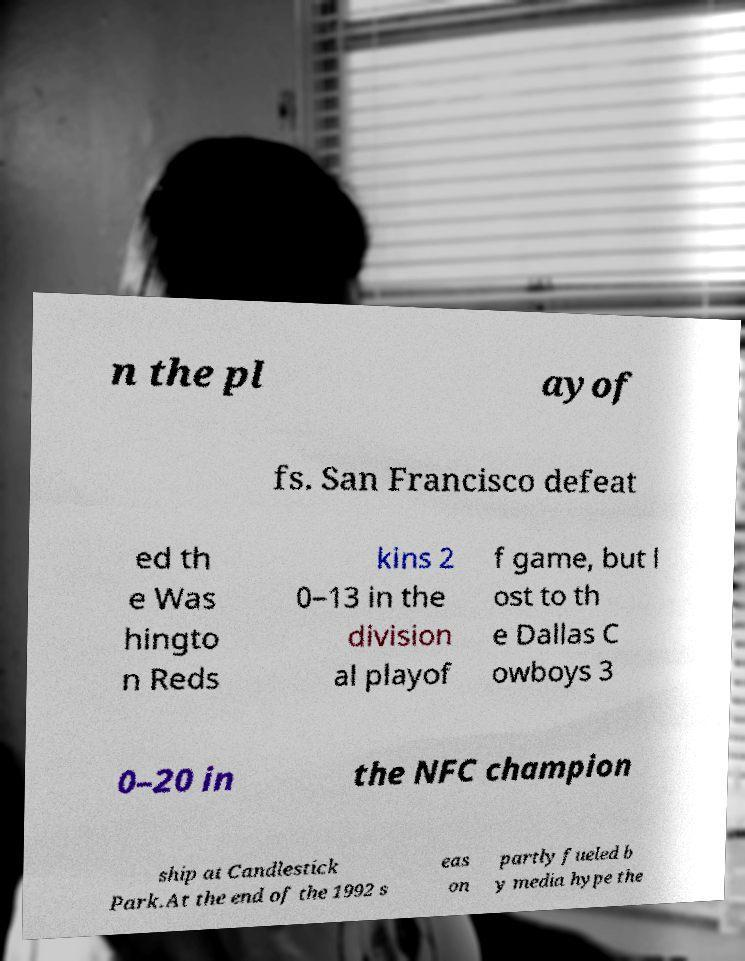I need the written content from this picture converted into text. Can you do that? n the pl ayof fs. San Francisco defeat ed th e Was hingto n Reds kins 2 0–13 in the division al playof f game, but l ost to th e Dallas C owboys 3 0–20 in the NFC champion ship at Candlestick Park.At the end of the 1992 s eas on partly fueled b y media hype the 